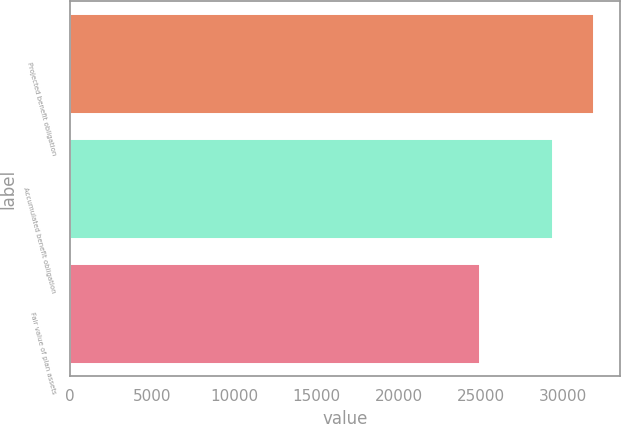<chart> <loc_0><loc_0><loc_500><loc_500><bar_chart><fcel>Projected benefit obligation<fcel>Accumulated benefit obligation<fcel>Fair value of plan assets<nl><fcel>31868<fcel>29382<fcel>24941<nl></chart> 